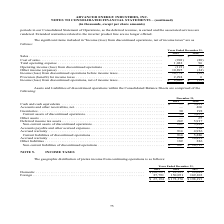According to Advanced Energy's financial document, What was the cost of sales in 2019? According to the financial document, (901) (in thousands). The relevant text states: "Cost of sales . (901) (88) Total operating expense . 1,022 96 Operating income (loss) from discontinued operations . (121)..." Also, What was the Total operating expense in 2018? According to the financial document, 96 (in thousands). The relevant text states: "ales . (901) (88) Total operating expense . 1,022 96 Operating income (loss) from discontinued operations . (121) (8)..." Also, What was the Provision (benefit) for income taxes in 2018? According to the financial document, 6 (in thousands). The relevant text states: "les . (901) (88) Total operating expense . 1,022 96 Operating income (loss) from discontinued operations . (121) (8)..." Also, can you calculate: What was the change in Provision (benefit) for income taxes between 2018 and 2019? Based on the calculation: 2,294-6, the result is 2288 (in thousands). This is based on the information: "Provision (benefit) for income taxes . 2,294 6 Income (loss) from discontinued operations, net of income taxes . $ 8,480 $ (38) Provision (benefit) for income taxes . 2,294 6 Income (loss) from discon..." The key data points involved are: 2,294, 6. Also, can you calculate: What was the percentage change in Cost of sales between 2018 and 2019? To answer this question, I need to perform calculations using the financial data. The calculation is: (-901-(-88))/-88, which equals 923.86 (percentage). This is based on the information: "Cost of sales . (901) (88) Total operating expense . 1,022 96 Operating income (loss) from discontinued operations . (12 Cost of sales . (901) (88) Total operating expense . 1,022 96 Operating income ..." The key data points involved are: 88, 901. Also, can you calculate: What was the percentage change in Income (loss) from discontinued operations, net of income taxes between 2018 and 2019? To answer this question, I need to perform calculations using the financial data. The calculation is: ($8,480-(-$38))/-$38, which equals -22415.79 (percentage). This is based on the information: "nued operations, net of income taxes . $ 8,480 $ (38) discontinued operations, net of income taxes . $ 8,480 $ (38)..." The key data points involved are: 38, 8,480. 